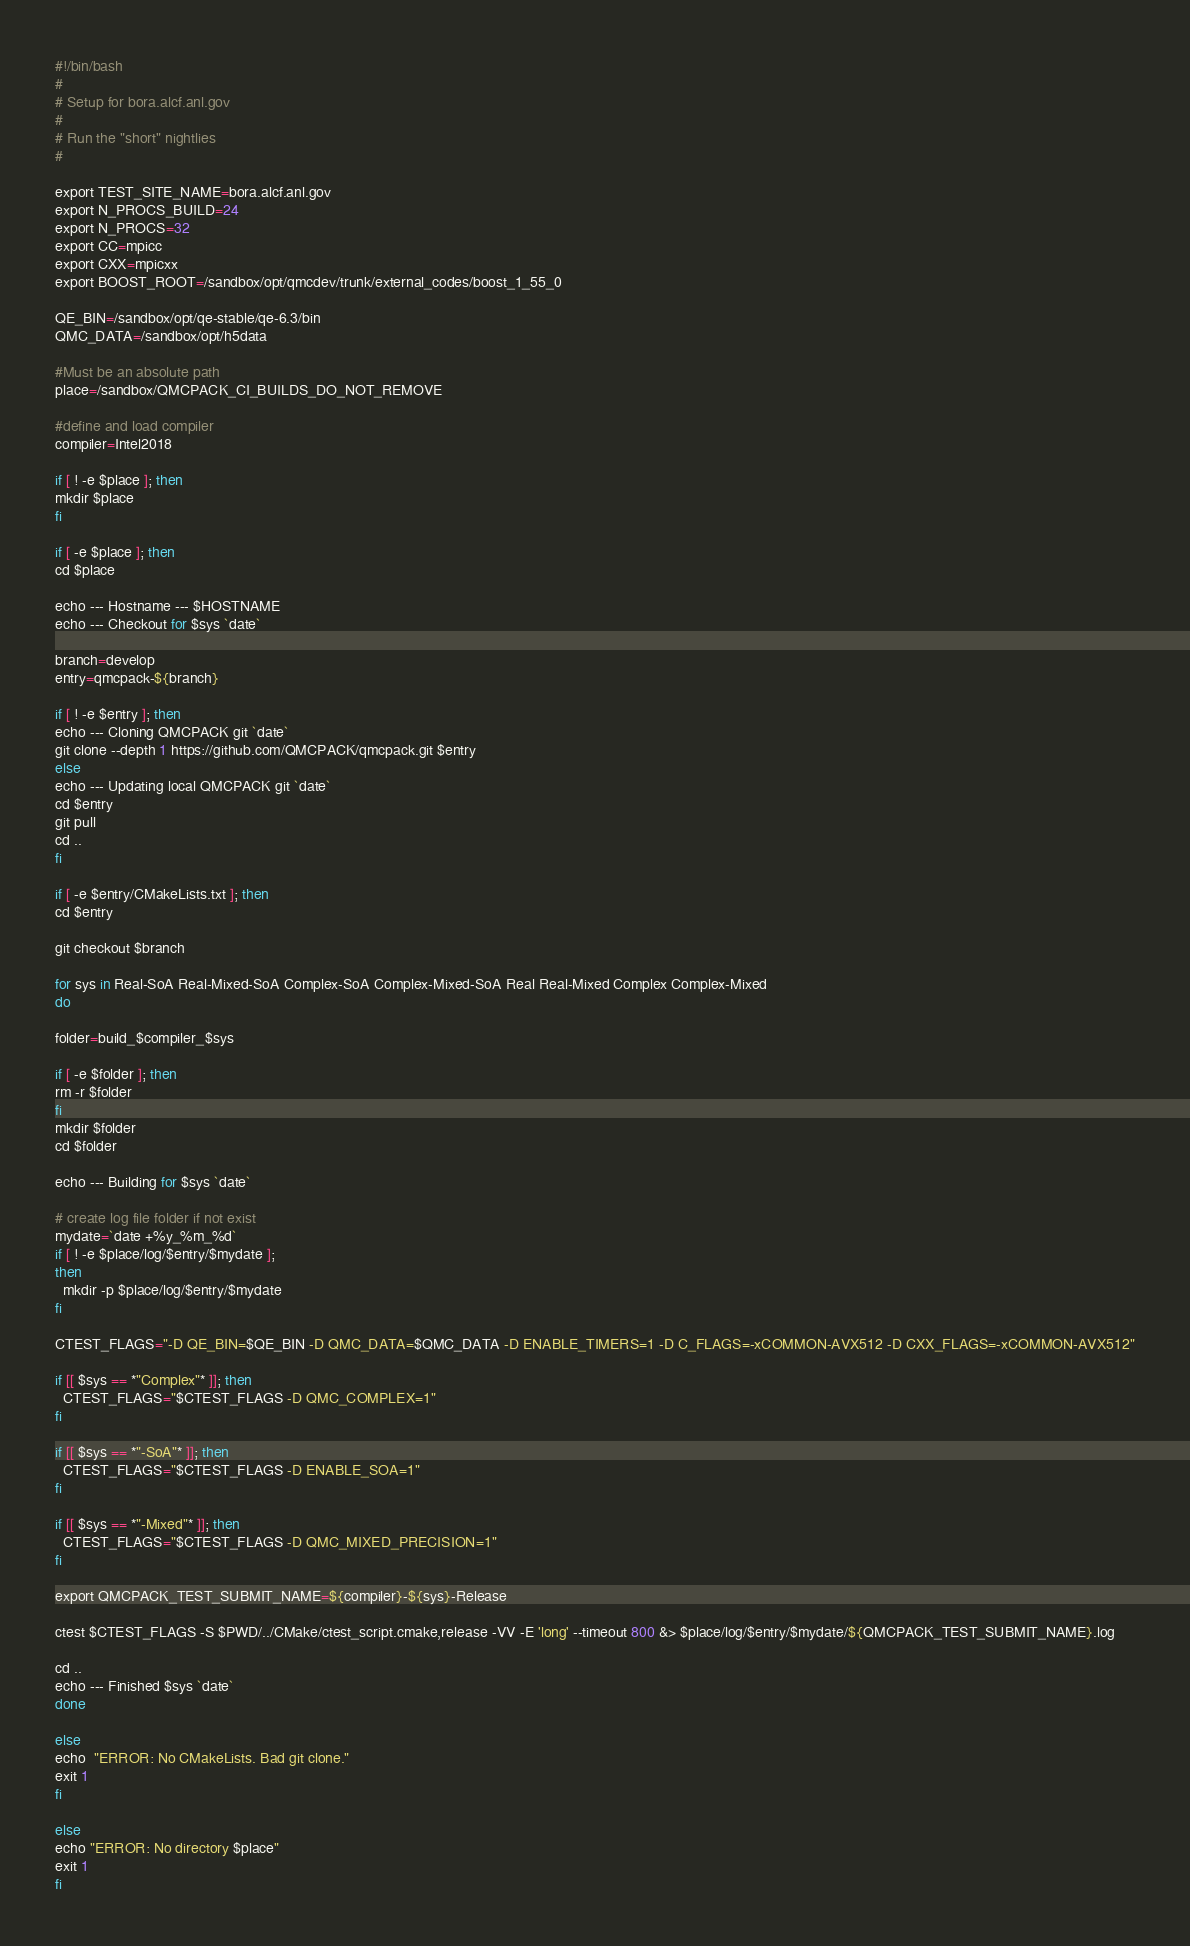<code> <loc_0><loc_0><loc_500><loc_500><_Bash_>#!/bin/bash
#
# Setup for bora.alcf.anl.gov
#
# Run the "short" nightlies
# 

export TEST_SITE_NAME=bora.alcf.anl.gov
export N_PROCS_BUILD=24
export N_PROCS=32
export CC=mpicc
export CXX=mpicxx
export BOOST_ROOT=/sandbox/opt/qmcdev/trunk/external_codes/boost_1_55_0

QE_BIN=/sandbox/opt/qe-stable/qe-6.3/bin
QMC_DATA=/sandbox/opt/h5data

#Must be an absolute path
place=/sandbox/QMCPACK_CI_BUILDS_DO_NOT_REMOVE

#define and load compiler
compiler=Intel2018

if [ ! -e $place ]; then
mkdir $place
fi

if [ -e $place ]; then
cd $place

echo --- Hostname --- $HOSTNAME
echo --- Checkout for $sys `date`

branch=develop
entry=qmcpack-${branch}

if [ ! -e $entry ]; then
echo --- Cloning QMCPACK git `date`
git clone --depth 1 https://github.com/QMCPACK/qmcpack.git $entry
else
echo --- Updating local QMCPACK git `date`
cd $entry
git pull
cd ..
fi

if [ -e $entry/CMakeLists.txt ]; then
cd $entry

git checkout $branch

for sys in Real-SoA Real-Mixed-SoA Complex-SoA Complex-Mixed-SoA Real Real-Mixed Complex Complex-Mixed
do

folder=build_$compiler_$sys

if [ -e $folder ]; then
rm -r $folder
fi
mkdir $folder
cd $folder

echo --- Building for $sys `date`

# create log file folder if not exist
mydate=`date +%y_%m_%d`
if [ ! -e $place/log/$entry/$mydate ];
then
  mkdir -p $place/log/$entry/$mydate
fi

CTEST_FLAGS="-D QE_BIN=$QE_BIN -D QMC_DATA=$QMC_DATA -D ENABLE_TIMERS=1 -D C_FLAGS=-xCOMMON-AVX512 -D CXX_FLAGS=-xCOMMON-AVX512"

if [[ $sys == *"Complex"* ]]; then
  CTEST_FLAGS="$CTEST_FLAGS -D QMC_COMPLEX=1"
fi

if [[ $sys == *"-SoA"* ]]; then
  CTEST_FLAGS="$CTEST_FLAGS -D ENABLE_SOA=1"
fi

if [[ $sys == *"-Mixed"* ]]; then
  CTEST_FLAGS="$CTEST_FLAGS -D QMC_MIXED_PRECISION=1"
fi

export QMCPACK_TEST_SUBMIT_NAME=${compiler}-${sys}-Release

ctest $CTEST_FLAGS -S $PWD/../CMake/ctest_script.cmake,release -VV -E 'long' --timeout 800 &> $place/log/$entry/$mydate/${QMCPACK_TEST_SUBMIT_NAME}.log

cd ..
echo --- Finished $sys `date`
done

else
echo  "ERROR: No CMakeLists. Bad git clone."
exit 1
fi

else
echo "ERROR: No directory $place"
exit 1
fi
</code> 